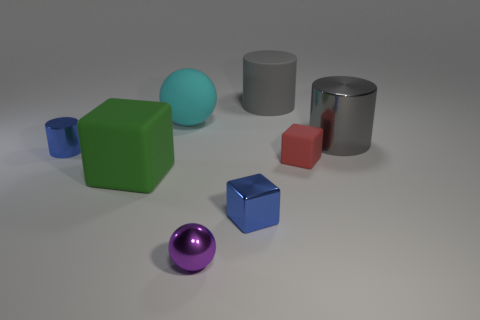How many things are blue objects left of the big green matte thing or gray cylinders that are in front of the gray rubber thing?
Offer a terse response. 2. Do the cyan thing behind the tiny red object and the metallic cylinder left of the small red block have the same size?
Your answer should be very brief. No. There is a large thing that is the same shape as the tiny red object; what color is it?
Provide a succinct answer. Green. Is there any other thing that is the same shape as the purple object?
Provide a short and direct response. Yes. Is the number of tiny matte blocks that are on the left side of the small cylinder greater than the number of rubber objects in front of the gray shiny cylinder?
Your response must be concise. No. What size is the blue object that is in front of the small cylinder behind the small blue metal thing that is in front of the tiny red matte object?
Provide a short and direct response. Small. Does the small blue cylinder have the same material as the small blue block that is to the right of the purple object?
Your answer should be compact. Yes. Does the purple thing have the same shape as the big cyan rubber thing?
Offer a very short reply. Yes. What number of other objects are there of the same material as the tiny blue cylinder?
Make the answer very short. 3. How many gray things are the same shape as the red thing?
Your response must be concise. 0. 